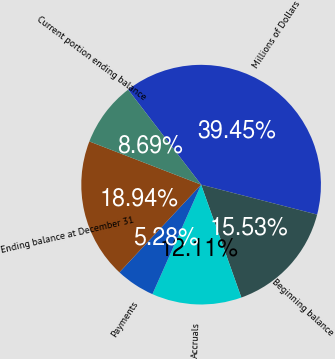Convert chart to OTSL. <chart><loc_0><loc_0><loc_500><loc_500><pie_chart><fcel>Millions of Dollars<fcel>Beginning balance<fcel>Accruals<fcel>Payments<fcel>Ending balance at December 31<fcel>Current portion ending balance<nl><fcel>39.45%<fcel>15.53%<fcel>12.11%<fcel>5.28%<fcel>18.94%<fcel>8.69%<nl></chart> 